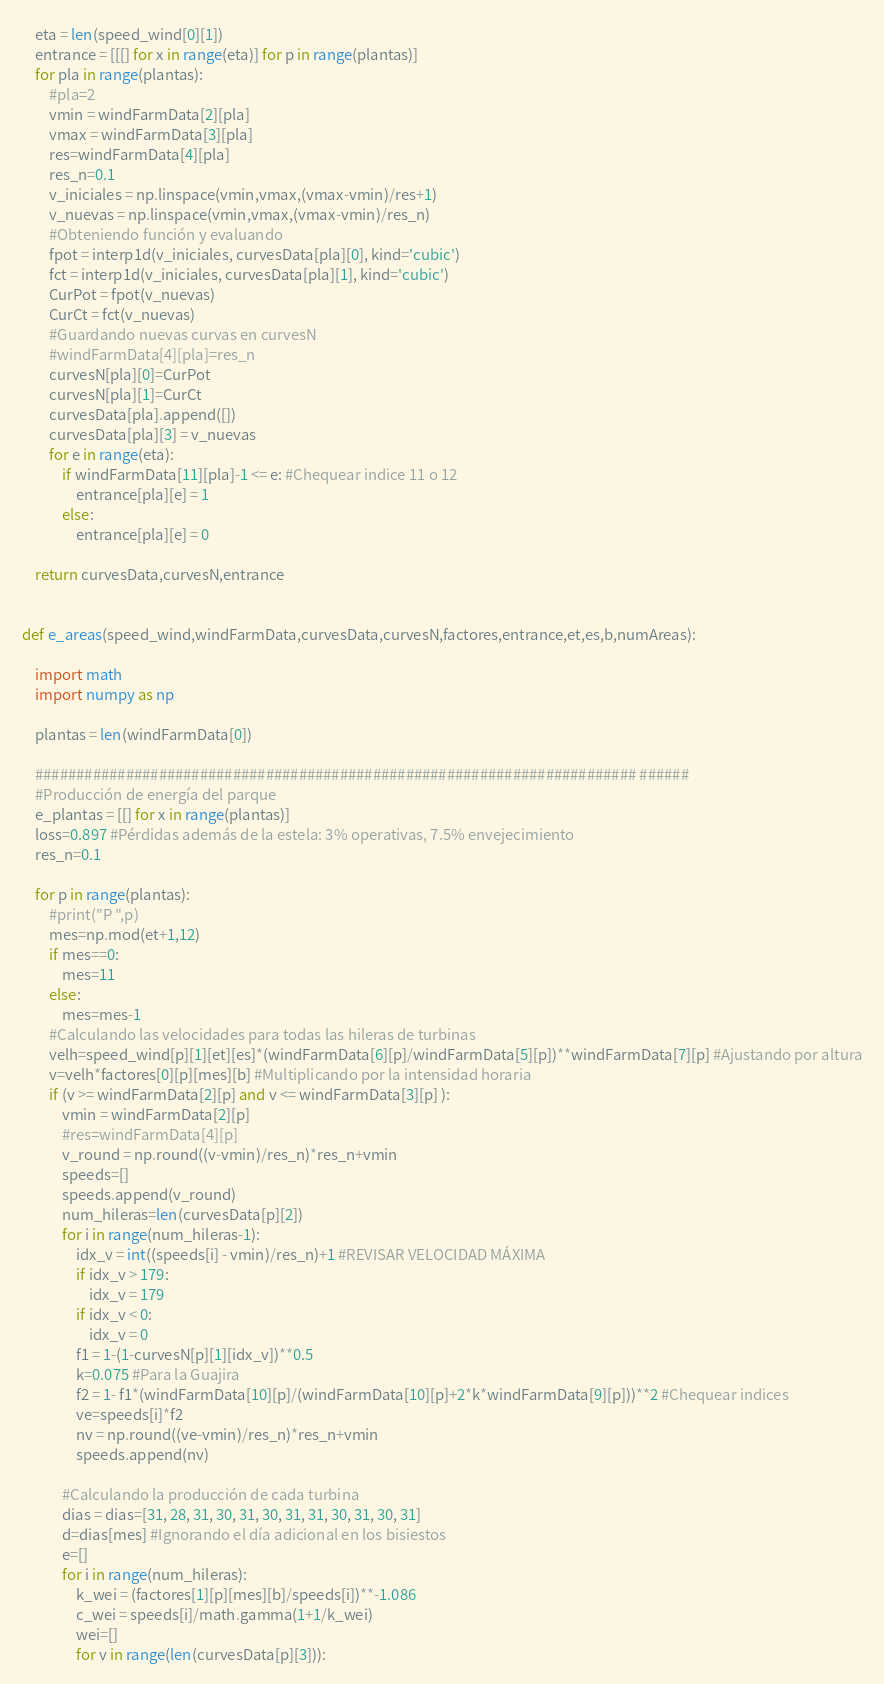<code> <loc_0><loc_0><loc_500><loc_500><_Python_>    eta = len(speed_wind[0][1])
    entrance = [[[] for x in range(eta)] for p in range(plantas)]
    for pla in range(plantas):
        #pla=2
        vmin = windFarmData[2][pla]
        vmax = windFarmData[3][pla]
        res=windFarmData[4][pla]
        res_n=0.1
        v_iniciales = np.linspace(vmin,vmax,(vmax-vmin)/res+1)
        v_nuevas = np.linspace(vmin,vmax,(vmax-vmin)/res_n)
        #Obteniendo función y evaluando
        fpot = interp1d(v_iniciales, curvesData[pla][0], kind='cubic')
        fct = interp1d(v_iniciales, curvesData[pla][1], kind='cubic')
        CurPot = fpot(v_nuevas)
        CurCt = fct(v_nuevas)
        #Guardando nuevas curvas en curvesN
        #windFarmData[4][pla]=res_n
        curvesN[pla][0]=CurPot
        curvesN[pla][1]=CurCt
        curvesData[pla].append([])
        curvesData[pla][3] = v_nuevas
        for e in range(eta):
            if windFarmData[11][pla]-1 <= e: #Chequear indice 11 o 12
                entrance[pla][e] = 1
            else:
                entrance[pla][e] = 0
        
    return curvesData,curvesN,entrance


def e_areas(speed_wind,windFarmData,curvesData,curvesN,factores,entrance,et,es,b,numAreas): 
    
    import math
    import numpy as np
    
    plantas = len(windFarmData[0])

    ######################################################################### ######
    #Producción de energía del parque
    e_plantas = [[] for x in range(plantas)]
    loss=0.897 #Pérdidas además de la estela: 3% operativas, 7.5% envejecimiento
    res_n=0.1

    for p in range(plantas):
        #print("P ",p)
        mes=np.mod(et+1,12)
        if mes==0: 
            mes=11 
        else:
            mes=mes-1
        #Calculando las velocidades para todas las hileras de turbinas
        velh=speed_wind[p][1][et][es]*(windFarmData[6][p]/windFarmData[5][p])**windFarmData[7][p] #Ajustando por altura
        v=velh*factores[0][p][mes][b] #Multiplicando por la intensidad horaria
        if (v >= windFarmData[2][p] and v <= windFarmData[3][p] ):
            vmin = windFarmData[2][p]
            #res=windFarmData[4][p]
            v_round = np.round((v-vmin)/res_n)*res_n+vmin                  
            speeds=[]        
            speeds.append(v_round)
            num_hileras=len(curvesData[p][2])          
            for i in range(num_hileras-1):
                idx_v = int((speeds[i] - vmin)/res_n)+1 #REVISAR VELOCIDAD MÁXIMA
                if idx_v > 179:
                    idx_v = 179
                if idx_v < 0:
                    idx_v = 0
                f1 = 1-(1-curvesN[p][1][idx_v])**0.5
                k=0.075 #Para la Guajira
                f2 = 1- f1*(windFarmData[10][p]/(windFarmData[10][p]+2*k*windFarmData[9][p]))**2 #Chequear indices
                ve=speeds[i]*f2
                nv = np.round((ve-vmin)/res_n)*res_n+vmin 
                speeds.append(nv)
            
            #Calculando la producción de cada turbina
            dias = dias=[31, 28, 31, 30, 31, 30, 31, 31, 30, 31, 30, 31]
            d=dias[mes] #Ignorando el día adicional en los bisiestos
            e=[]
            for i in range(num_hileras):     
                k_wei = (factores[1][p][mes][b]/speeds[i])**-1.086
                c_wei = speeds[i]/math.gamma(1+1/k_wei)
                wei=[]
                for v in range(len(curvesData[p][3])):</code> 